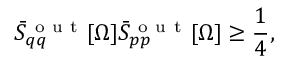Convert formula to latex. <formula><loc_0><loc_0><loc_500><loc_500>\ B a r { S } _ { q q } ^ { o u t } [ \Omega ] \ B a r { S } _ { p p } ^ { o u t } [ \Omega ] \geq \frac { 1 } { 4 } ,</formula> 